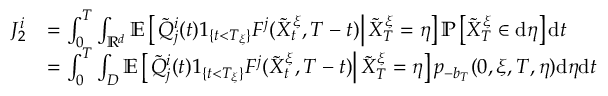<formula> <loc_0><loc_0><loc_500><loc_500>\begin{array} { r l } { J _ { 2 } ^ { i } } & { = \int _ { 0 } ^ { T } \int _ { \mathbb { R } ^ { d } } \mathbb { E } \left [ \tilde { Q } _ { j } ^ { i } ( t ) 1 _ { \{ t < T _ { \xi } \} } F ^ { j } ( \tilde { X } _ { t } ^ { \xi } , T - t ) \right | \tilde { X } _ { T } ^ { \xi } = \eta \right ] \mathbb { P } \left [ \tilde { X } _ { T } ^ { \xi } \in d \eta \right ] d t } \\ & { = \int _ { 0 } ^ { T } \int _ { D } \mathbb { E } \left [ \tilde { Q } _ { j } ^ { i } ( t ) 1 _ { \{ t < T _ { \xi } \} } F ^ { j } ( \tilde { X } _ { t } ^ { \xi } , T - t ) \right | \tilde { X } _ { T } ^ { \xi } = \eta \right ] p _ { - b _ { T } } ( 0 , \xi , T , \eta ) d \eta d t } \end{array}</formula> 